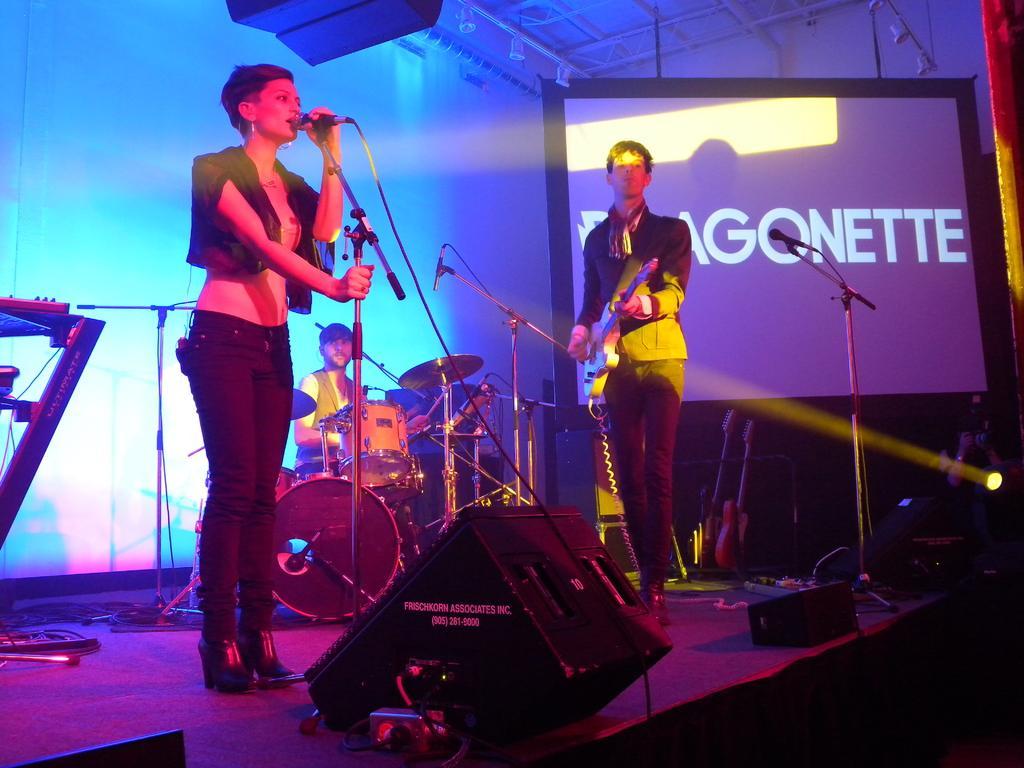Describe this image in one or two sentences. In this image I can see three people and these people are playing the musical instruments. To the Right there is a screen. 